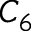<formula> <loc_0><loc_0><loc_500><loc_500>C _ { 6 }</formula> 